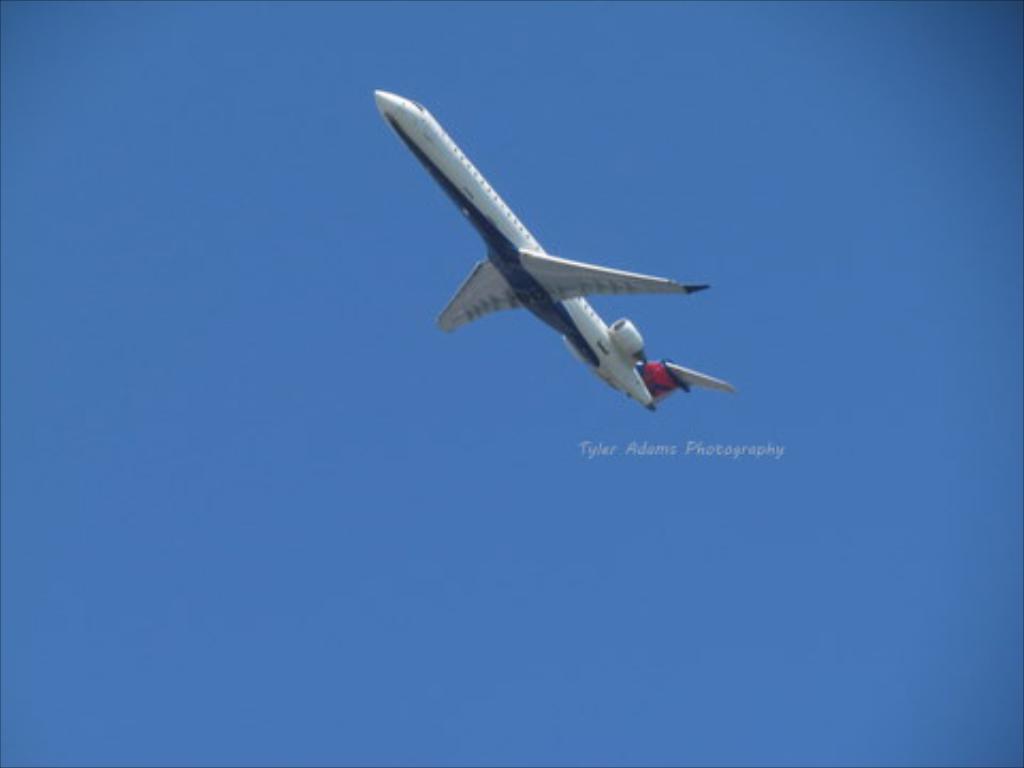Please provide a concise description of this image. In this image, I can see an airplane flying. This is the sky, which is blue in color. I think this is the watermark on the image. 